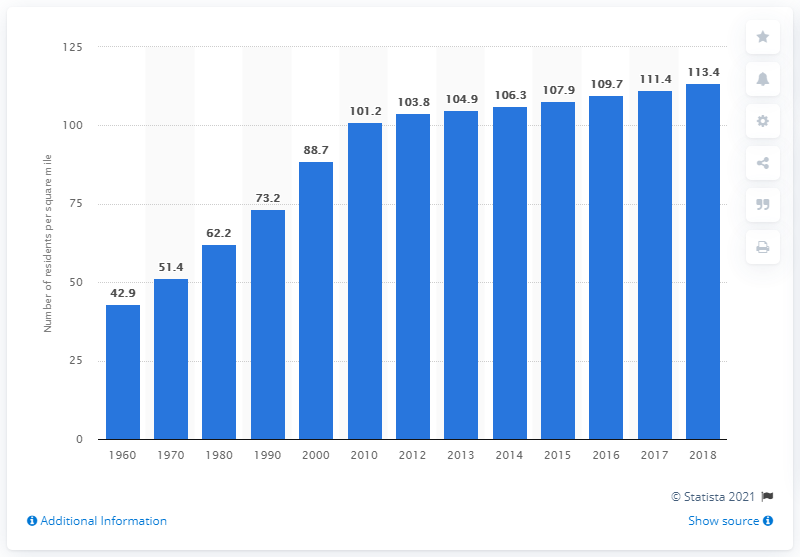List a handful of essential elements in this visual. In 2018, the population density of Washington was 113.4 people per square mile. 